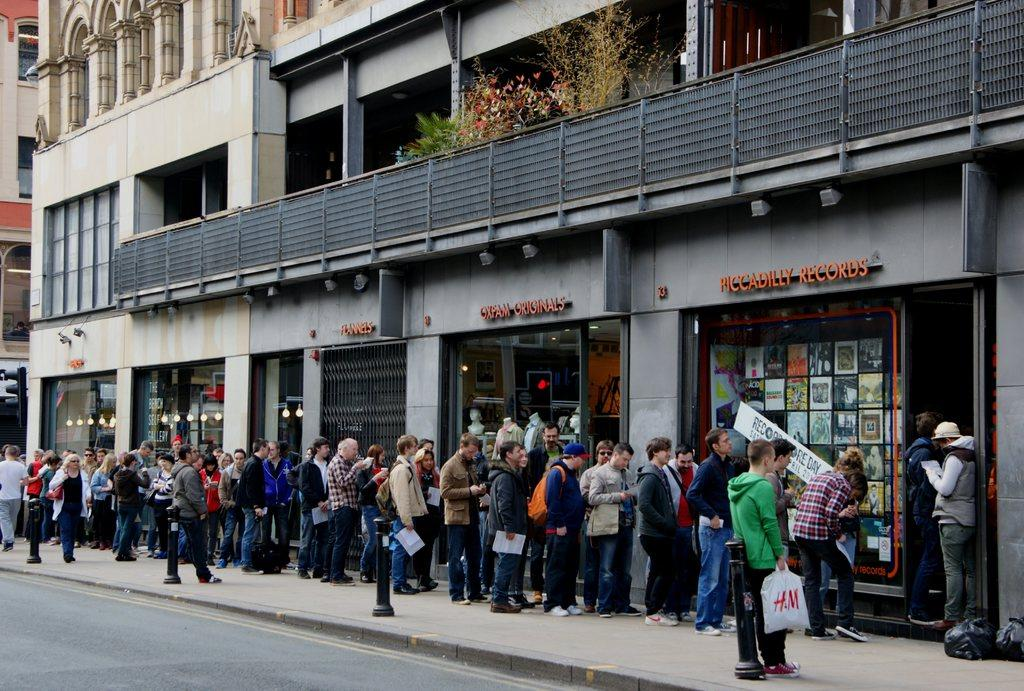<image>
Provide a brief description of the given image. A crowd of people is lined up on the sidewalk in front of Piccadilly Records. 